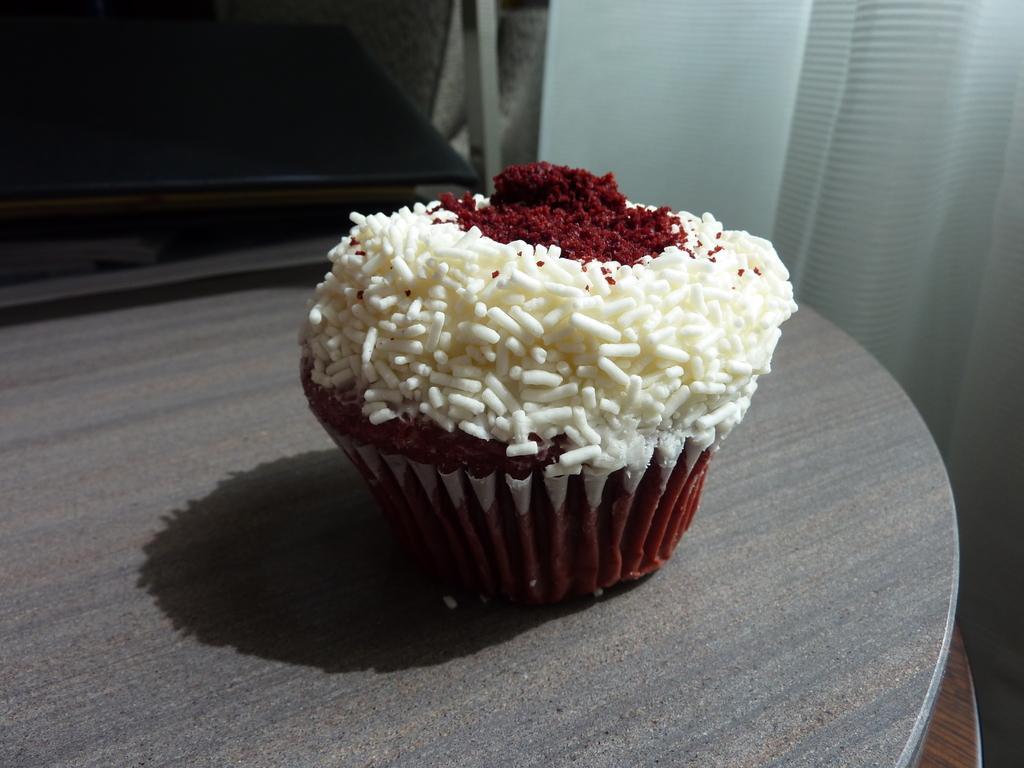How would you summarize this image in a sentence or two? In this image I can see a cupcake on the grey color table. Cupcake is in white and maroon color. Background is in white and black color. 